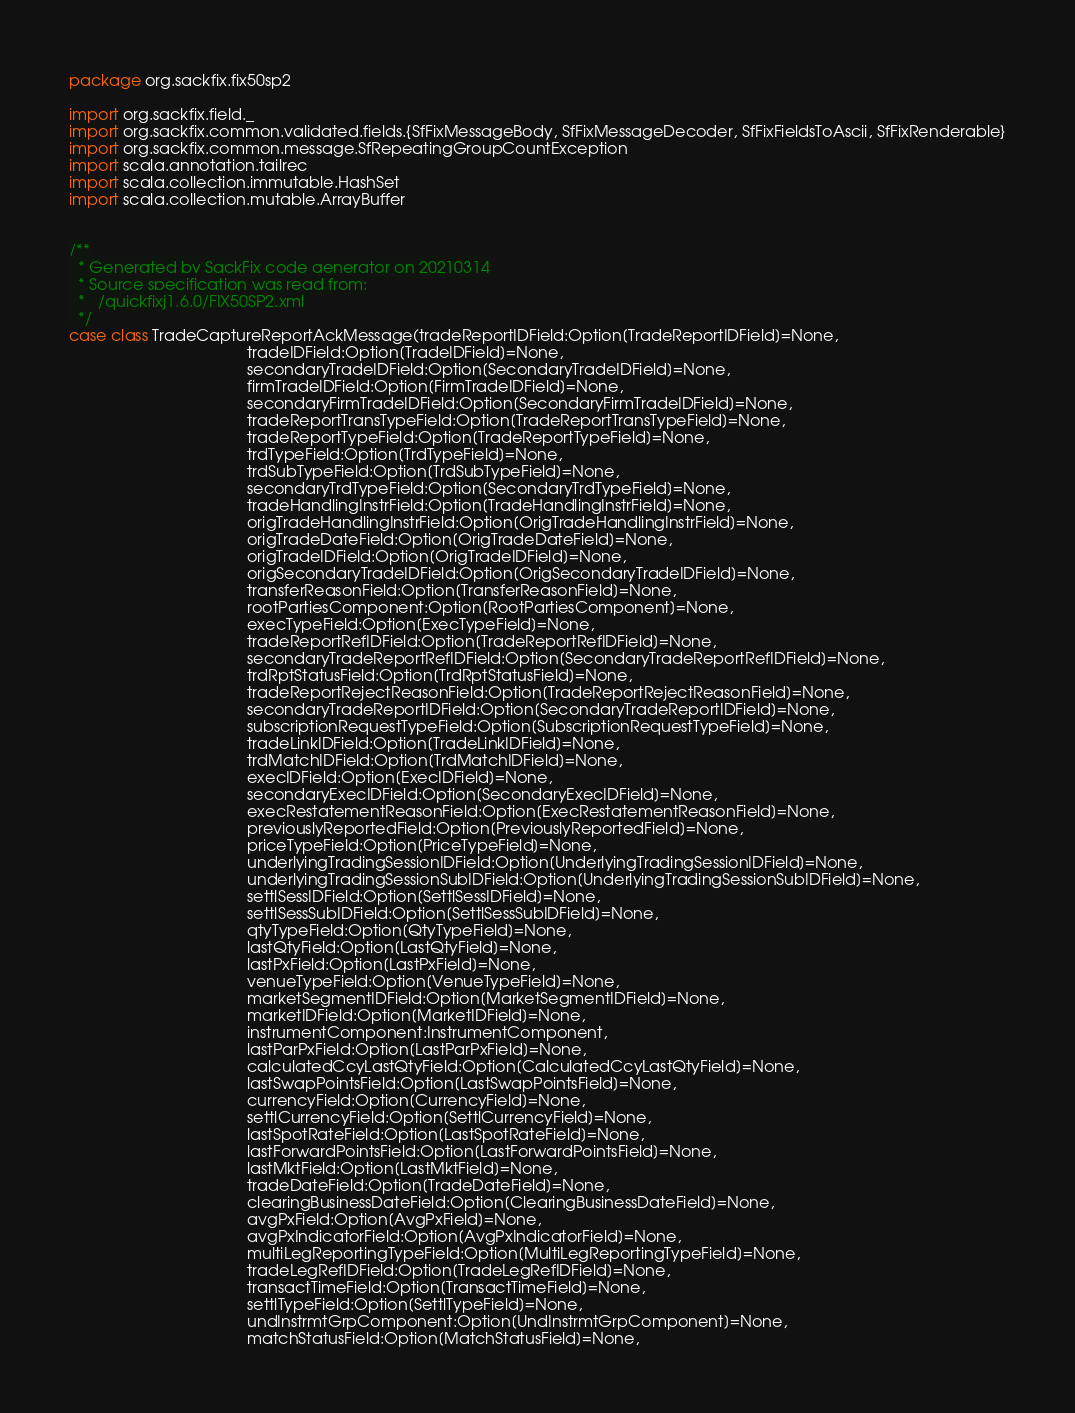Convert code to text. <code><loc_0><loc_0><loc_500><loc_500><_Scala_>package org.sackfix.fix50sp2

import org.sackfix.field._
import org.sackfix.common.validated.fields.{SfFixMessageBody, SfFixMessageDecoder, SfFixFieldsToAscii, SfFixRenderable}
import org.sackfix.common.message.SfRepeatingGroupCountException
import scala.annotation.tailrec
import scala.collection.immutable.HashSet
import scala.collection.mutable.ArrayBuffer


/**
  * Generated by SackFix code generator on 20210314
  * Source specification was read from:
  *   /quickfixj1.6.0/FIX50SP2.xml
  */
case class TradeCaptureReportAckMessage(tradeReportIDField:Option[TradeReportIDField]=None,
                                        tradeIDField:Option[TradeIDField]=None,
                                        secondaryTradeIDField:Option[SecondaryTradeIDField]=None,
                                        firmTradeIDField:Option[FirmTradeIDField]=None,
                                        secondaryFirmTradeIDField:Option[SecondaryFirmTradeIDField]=None,
                                        tradeReportTransTypeField:Option[TradeReportTransTypeField]=None,
                                        tradeReportTypeField:Option[TradeReportTypeField]=None,
                                        trdTypeField:Option[TrdTypeField]=None,
                                        trdSubTypeField:Option[TrdSubTypeField]=None,
                                        secondaryTrdTypeField:Option[SecondaryTrdTypeField]=None,
                                        tradeHandlingInstrField:Option[TradeHandlingInstrField]=None,
                                        origTradeHandlingInstrField:Option[OrigTradeHandlingInstrField]=None,
                                        origTradeDateField:Option[OrigTradeDateField]=None,
                                        origTradeIDField:Option[OrigTradeIDField]=None,
                                        origSecondaryTradeIDField:Option[OrigSecondaryTradeIDField]=None,
                                        transferReasonField:Option[TransferReasonField]=None,
                                        rootPartiesComponent:Option[RootPartiesComponent]=None,
                                        execTypeField:Option[ExecTypeField]=None,
                                        tradeReportRefIDField:Option[TradeReportRefIDField]=None,
                                        secondaryTradeReportRefIDField:Option[SecondaryTradeReportRefIDField]=None,
                                        trdRptStatusField:Option[TrdRptStatusField]=None,
                                        tradeReportRejectReasonField:Option[TradeReportRejectReasonField]=None,
                                        secondaryTradeReportIDField:Option[SecondaryTradeReportIDField]=None,
                                        subscriptionRequestTypeField:Option[SubscriptionRequestTypeField]=None,
                                        tradeLinkIDField:Option[TradeLinkIDField]=None,
                                        trdMatchIDField:Option[TrdMatchIDField]=None,
                                        execIDField:Option[ExecIDField]=None,
                                        secondaryExecIDField:Option[SecondaryExecIDField]=None,
                                        execRestatementReasonField:Option[ExecRestatementReasonField]=None,
                                        previouslyReportedField:Option[PreviouslyReportedField]=None,
                                        priceTypeField:Option[PriceTypeField]=None,
                                        underlyingTradingSessionIDField:Option[UnderlyingTradingSessionIDField]=None,
                                        underlyingTradingSessionSubIDField:Option[UnderlyingTradingSessionSubIDField]=None,
                                        settlSessIDField:Option[SettlSessIDField]=None,
                                        settlSessSubIDField:Option[SettlSessSubIDField]=None,
                                        qtyTypeField:Option[QtyTypeField]=None,
                                        lastQtyField:Option[LastQtyField]=None,
                                        lastPxField:Option[LastPxField]=None,
                                        venueTypeField:Option[VenueTypeField]=None,
                                        marketSegmentIDField:Option[MarketSegmentIDField]=None,
                                        marketIDField:Option[MarketIDField]=None,
                                        instrumentComponent:InstrumentComponent,
                                        lastParPxField:Option[LastParPxField]=None,
                                        calculatedCcyLastQtyField:Option[CalculatedCcyLastQtyField]=None,
                                        lastSwapPointsField:Option[LastSwapPointsField]=None,
                                        currencyField:Option[CurrencyField]=None,
                                        settlCurrencyField:Option[SettlCurrencyField]=None,
                                        lastSpotRateField:Option[LastSpotRateField]=None,
                                        lastForwardPointsField:Option[LastForwardPointsField]=None,
                                        lastMktField:Option[LastMktField]=None,
                                        tradeDateField:Option[TradeDateField]=None,
                                        clearingBusinessDateField:Option[ClearingBusinessDateField]=None,
                                        avgPxField:Option[AvgPxField]=None,
                                        avgPxIndicatorField:Option[AvgPxIndicatorField]=None,
                                        multiLegReportingTypeField:Option[MultiLegReportingTypeField]=None,
                                        tradeLegRefIDField:Option[TradeLegRefIDField]=None,
                                        transactTimeField:Option[TransactTimeField]=None,
                                        settlTypeField:Option[SettlTypeField]=None,
                                        undInstrmtGrpComponent:Option[UndInstrmtGrpComponent]=None,
                                        matchStatusField:Option[MatchStatusField]=None,</code> 